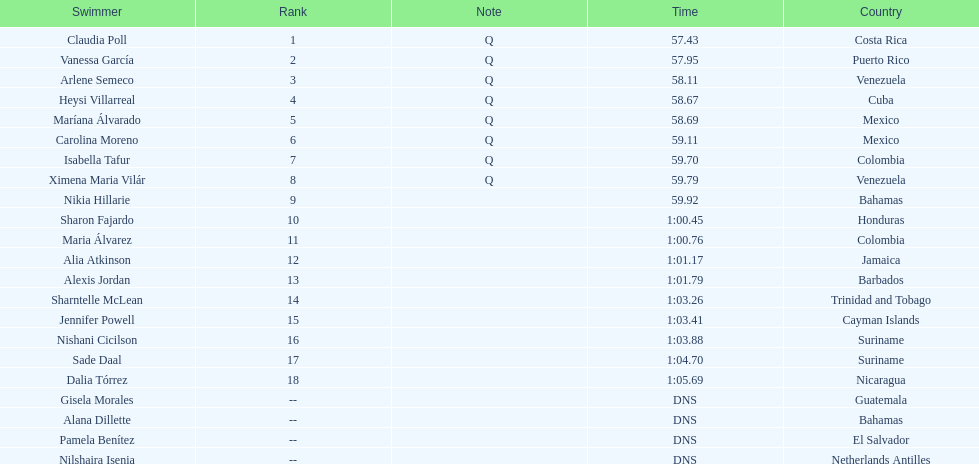How many competitors did not start the preliminaries? 4. 